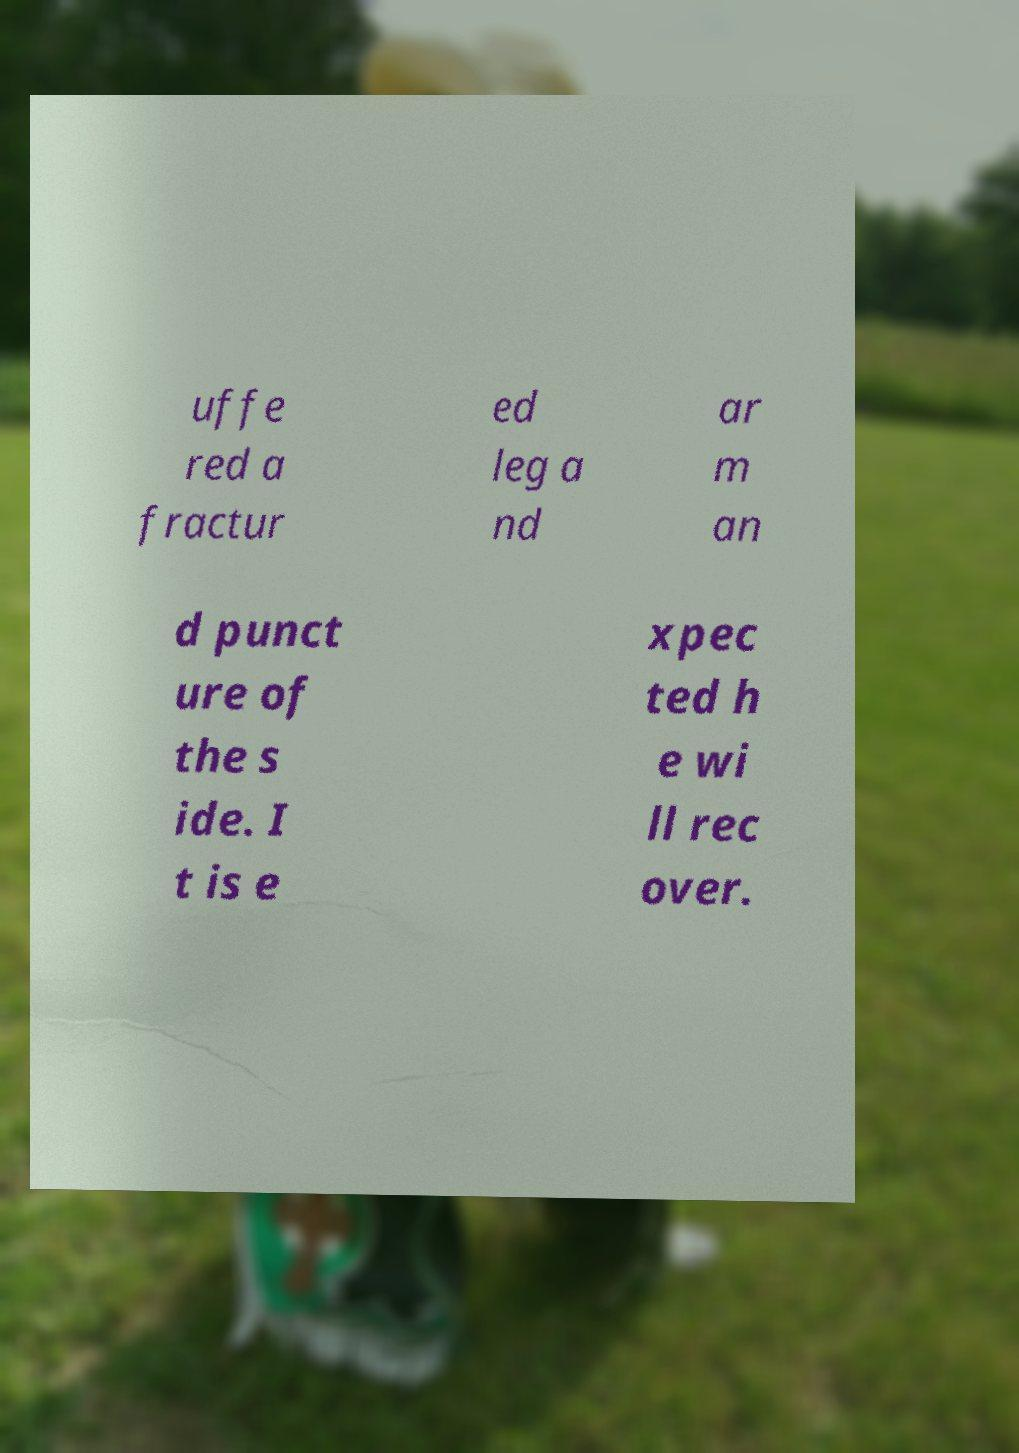Could you assist in decoding the text presented in this image and type it out clearly? uffe red a fractur ed leg a nd ar m an d punct ure of the s ide. I t is e xpec ted h e wi ll rec over. 